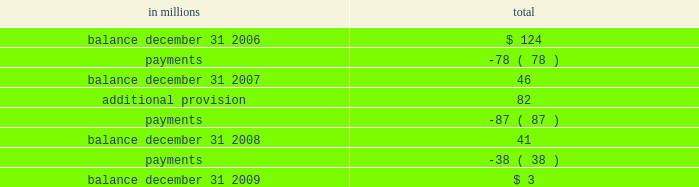Working on the site .
The company resolved five of the eight pending lawsuits arising from this matter and believes that it has adequate insurance to resolve remaining matters .
The company believes that the settlement of these lawsuits will not have a material adverse effect on its consolidated financial statements .
During the 2009 third quarter , in connection with an environmental site remediation action under cer- cla , international paper submitted to the epa a feasibility study for this site .
The epa has indicated that it intends to select a proposed remedial action alternative from those identified in the study and present this proposal for public comment .
Since it is not currently possible to determine the final remedial action that will be required , the company has accrued , as of december 31 , 2009 , an estimate of the minimum costs that could be required for this site .
When the remediation plan is finalized by the epa , it is possible that the remediation costs could be sig- nificantly higher than amounts currently recorded .
Exterior siding and roofing litigation international paper has established reserves relating to the settlement , during 1998 and 1999 , of three nationwide class action lawsuits against the com- pany and masonite corp. , a former wholly-owned subsidiary of the company .
Those settlements relate to ( 1 ) exterior hardboard siding installed during the 1980 2019s and 1990 2019s ( the hardboard claims ) ; ( 2 ) omniwood siding installed during the 1990 2019s ( the omniwood claims ) ; and ( 3 ) woodruf roofing installed during the 1980 2019s and 1990 2019s ( the woodruf claims ) .
All hardboard claims were required to be made by january 15 , 2008 , while all omniwood and woodruf claims were required to be made by jan- uary 6 , 2009 .
The table presents an analysis of total reserve activity related to the hardboard , omniwood and woodruf settlements for the years ended december 31 , 2009 , 2008 and 2007 : in millions total .
The company believes that the aggregate reserve balance remaining at december 31 , 2009 is adequate to cover the final settlement of remaining claims .
Summary the company is also involved in various other inquiries , administrative proceedings and litigation relating to contracts , sales of property , intellectual property , environmental and safety matters , tax , personal injury , labor and employment and other matters , some of which allege substantial monetary damages .
While any proceeding or litigation has the element of uncertainty , the company believes that the outcome of any of the lawsuits or claims that are pending or threatened , or all of them combined , will not have a material adverse effect on its consolidated financial statements .
Note 12 variable interest entities and preferred securities of subsidiaries variable interest entities in connection with the 2006 sale of approximately 5.6 million acres of forestlands , international paper received installment notes ( the timber notes ) total- ing approximately $ 4.8 billion .
The timber notes , which do not require principal payments prior to their august 2016 maturity , are supported by irrev- ocable letters of credit obtained by the buyers of the forestlands .
During the 2006 fourth quarter , interna- tional paper contributed the timber notes to newly formed entities ( the borrower entities ) in exchange for class a and class b interests in these entities .
Subsequently , international paper contributed its $ 200 million class a interests in the borrower enti- ties , along with approximately $ 400 million of international paper promissory notes , to other newly formed entities ( the investor entities ) in exchange for class a and class b interests in these entities , and simultaneously sold its class a interest in the investor entities to a third party investor .
As a result , at december 31 , 2006 , international paper held class b interests in the borrower entities and class b interests in the investor entities valued at approx- imately $ 5.0 billion .
International paper has no obligation to make any further capital contributions to these entities and did not provide financial or other support during 2009 , 2008 or 2007 that was not previously contractually required .
Based on an analysis of these entities under guidance that considers the potential magnitude of the variability in the structure and which party bears a majority of the gains or losses , international paper determined that it is not the primary beneficiary of these entities .
Based on the review of the analysis of total reserve activity related to the hardboard , omniwood and woodruf settlements for the years ended december 31 , 2009 , 2008 and 2007 what was the sum of the payments? 
Computations: ((78 + 87) + 38)
Answer: 203.0. 